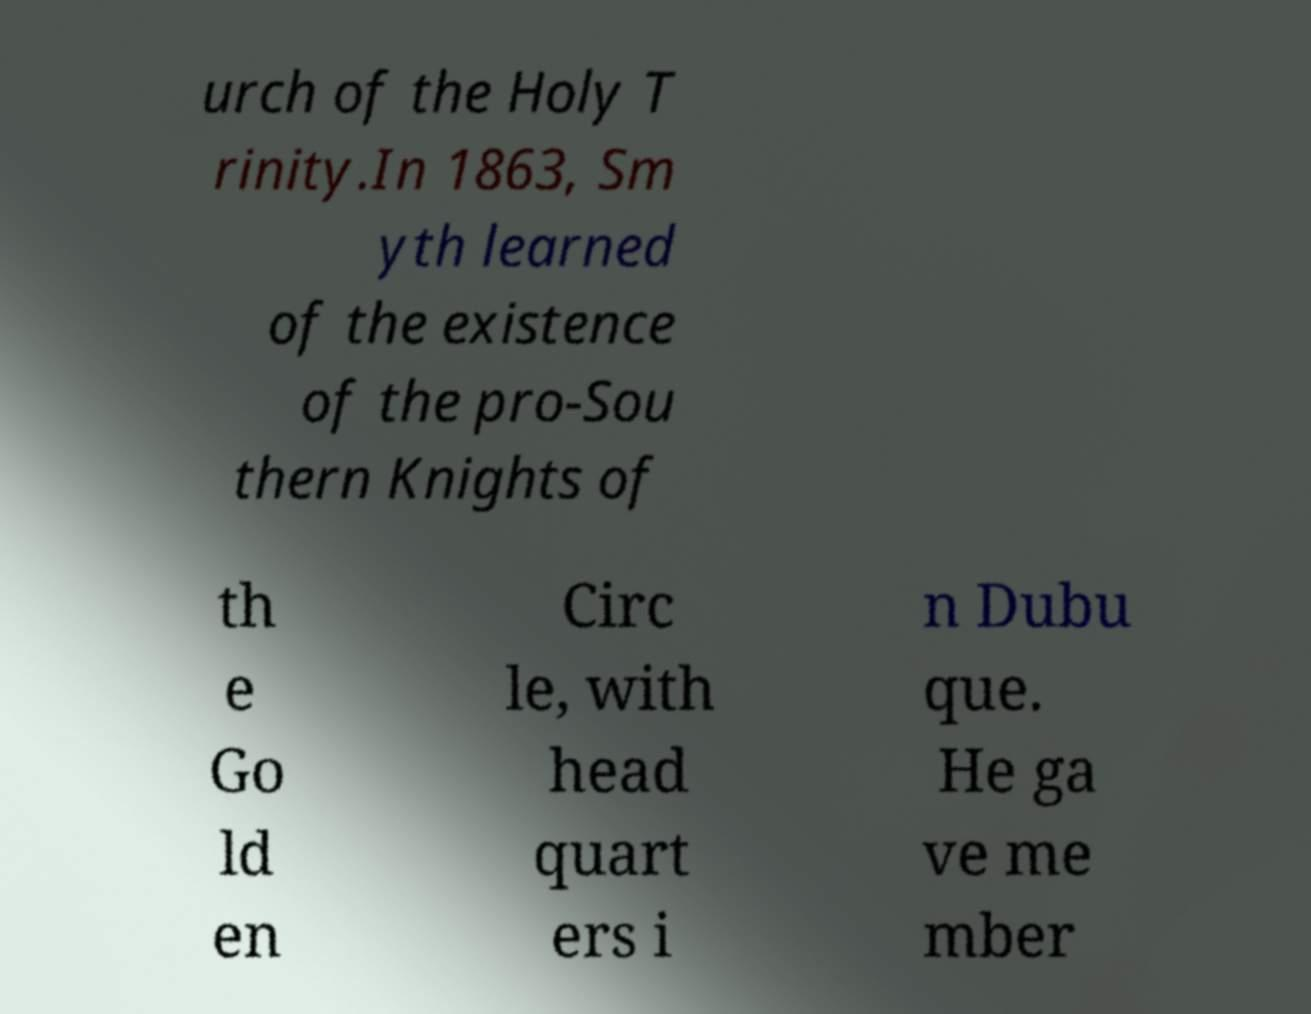What messages or text are displayed in this image? I need them in a readable, typed format. urch of the Holy T rinity.In 1863, Sm yth learned of the existence of the pro-Sou thern Knights of th e Go ld en Circ le, with head quart ers i n Dubu que. He ga ve me mber 